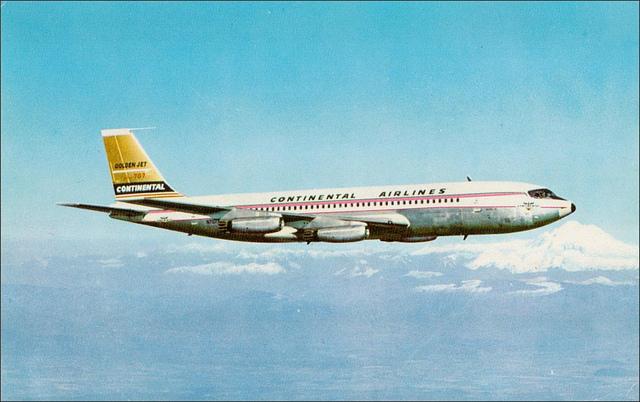Is the plane on the runway?
Be succinct. No. Is this a recent photograph?
Quick response, please. No. How many planes in the air?
Answer briefly. 1. What is the name of this airline?
Short answer required. Continental. Is it cloudy?
Keep it brief. No. What are the colors of the plane?
Quick response, please. White. 